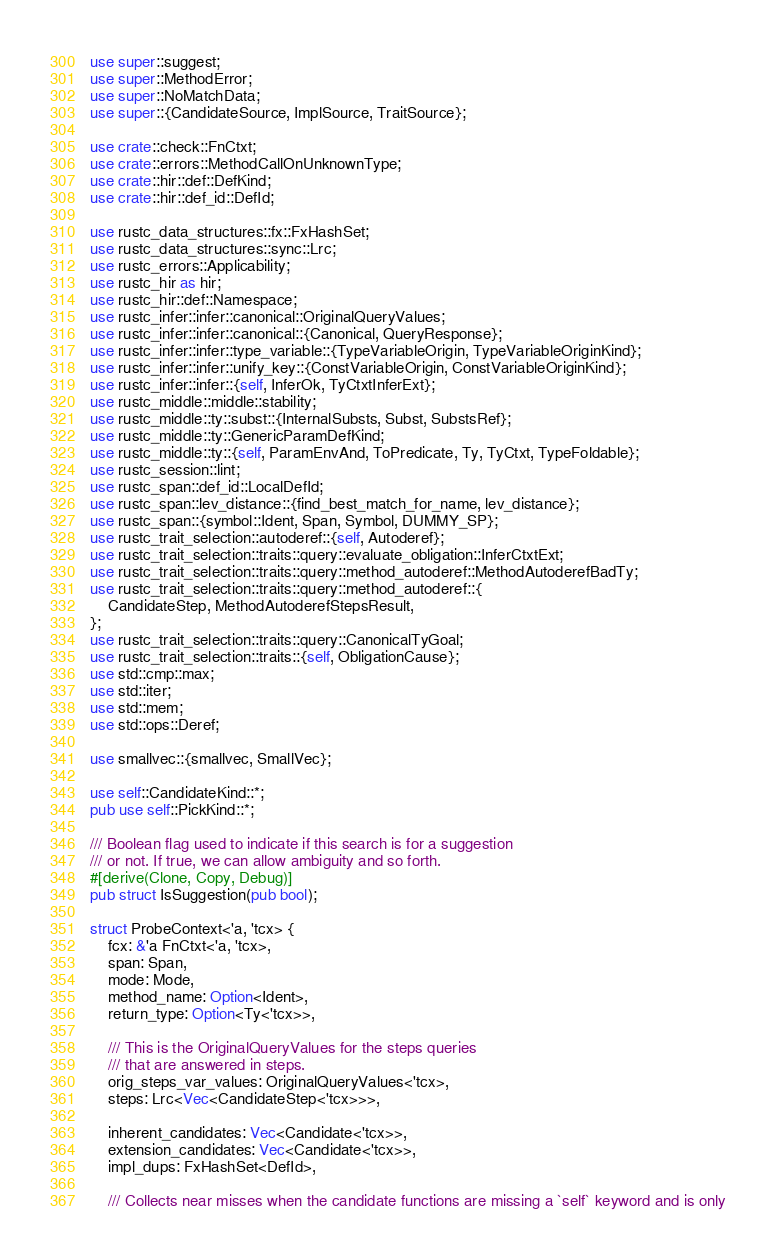Convert code to text. <code><loc_0><loc_0><loc_500><loc_500><_Rust_>use super::suggest;
use super::MethodError;
use super::NoMatchData;
use super::{CandidateSource, ImplSource, TraitSource};

use crate::check::FnCtxt;
use crate::errors::MethodCallOnUnknownType;
use crate::hir::def::DefKind;
use crate::hir::def_id::DefId;

use rustc_data_structures::fx::FxHashSet;
use rustc_data_structures::sync::Lrc;
use rustc_errors::Applicability;
use rustc_hir as hir;
use rustc_hir::def::Namespace;
use rustc_infer::infer::canonical::OriginalQueryValues;
use rustc_infer::infer::canonical::{Canonical, QueryResponse};
use rustc_infer::infer::type_variable::{TypeVariableOrigin, TypeVariableOriginKind};
use rustc_infer::infer::unify_key::{ConstVariableOrigin, ConstVariableOriginKind};
use rustc_infer::infer::{self, InferOk, TyCtxtInferExt};
use rustc_middle::middle::stability;
use rustc_middle::ty::subst::{InternalSubsts, Subst, SubstsRef};
use rustc_middle::ty::GenericParamDefKind;
use rustc_middle::ty::{self, ParamEnvAnd, ToPredicate, Ty, TyCtxt, TypeFoldable};
use rustc_session::lint;
use rustc_span::def_id::LocalDefId;
use rustc_span::lev_distance::{find_best_match_for_name, lev_distance};
use rustc_span::{symbol::Ident, Span, Symbol, DUMMY_SP};
use rustc_trait_selection::autoderef::{self, Autoderef};
use rustc_trait_selection::traits::query::evaluate_obligation::InferCtxtExt;
use rustc_trait_selection::traits::query::method_autoderef::MethodAutoderefBadTy;
use rustc_trait_selection::traits::query::method_autoderef::{
    CandidateStep, MethodAutoderefStepsResult,
};
use rustc_trait_selection::traits::query::CanonicalTyGoal;
use rustc_trait_selection::traits::{self, ObligationCause};
use std::cmp::max;
use std::iter;
use std::mem;
use std::ops::Deref;

use smallvec::{smallvec, SmallVec};

use self::CandidateKind::*;
pub use self::PickKind::*;

/// Boolean flag used to indicate if this search is for a suggestion
/// or not. If true, we can allow ambiguity and so forth.
#[derive(Clone, Copy, Debug)]
pub struct IsSuggestion(pub bool);

struct ProbeContext<'a, 'tcx> {
    fcx: &'a FnCtxt<'a, 'tcx>,
    span: Span,
    mode: Mode,
    method_name: Option<Ident>,
    return_type: Option<Ty<'tcx>>,

    /// This is the OriginalQueryValues for the steps queries
    /// that are answered in steps.
    orig_steps_var_values: OriginalQueryValues<'tcx>,
    steps: Lrc<Vec<CandidateStep<'tcx>>>,

    inherent_candidates: Vec<Candidate<'tcx>>,
    extension_candidates: Vec<Candidate<'tcx>>,
    impl_dups: FxHashSet<DefId>,

    /// Collects near misses when the candidate functions are missing a `self` keyword and is only</code> 